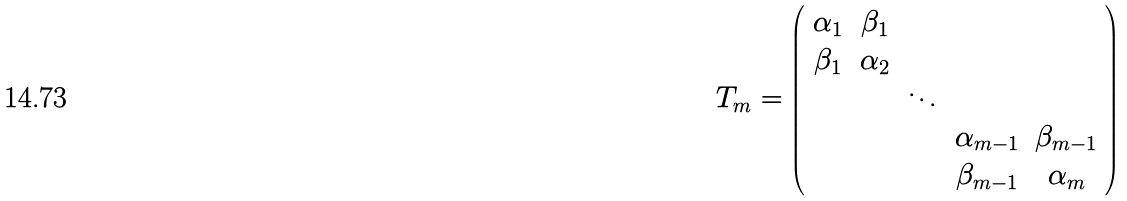<formula> <loc_0><loc_0><loc_500><loc_500>T _ { m } = \left ( \begin{array} { c c c c c } \alpha _ { 1 } & \beta _ { 1 } & & & \\ \beta _ { 1 } & \alpha _ { 2 } & & & \\ & & \ddots & & \\ & & & \alpha _ { m - 1 } & \beta _ { m - 1 } \\ & & & \beta _ { m - 1 } & \alpha _ { m } \\ \end{array} \right )</formula> 